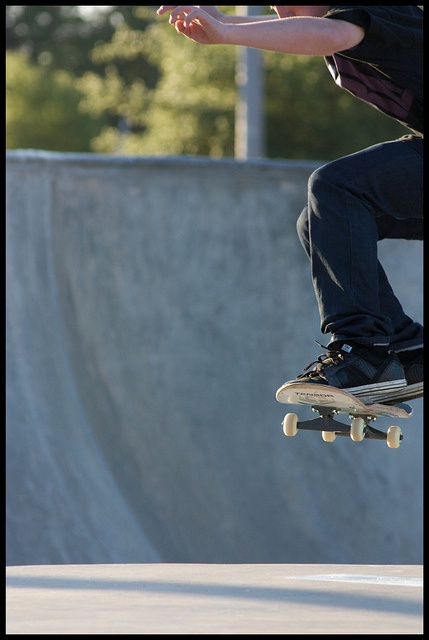Describe the objects in this image and their specific colors. I can see people in black and gray tones and skateboard in black, darkgray, and gray tones in this image. 